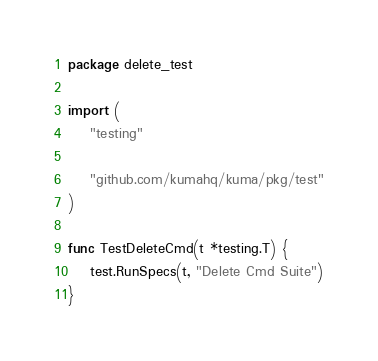Convert code to text. <code><loc_0><loc_0><loc_500><loc_500><_Go_>package delete_test

import (
	"testing"

	"github.com/kumahq/kuma/pkg/test"
)

func TestDeleteCmd(t *testing.T) {
	test.RunSpecs(t, "Delete Cmd Suite")
}
</code> 